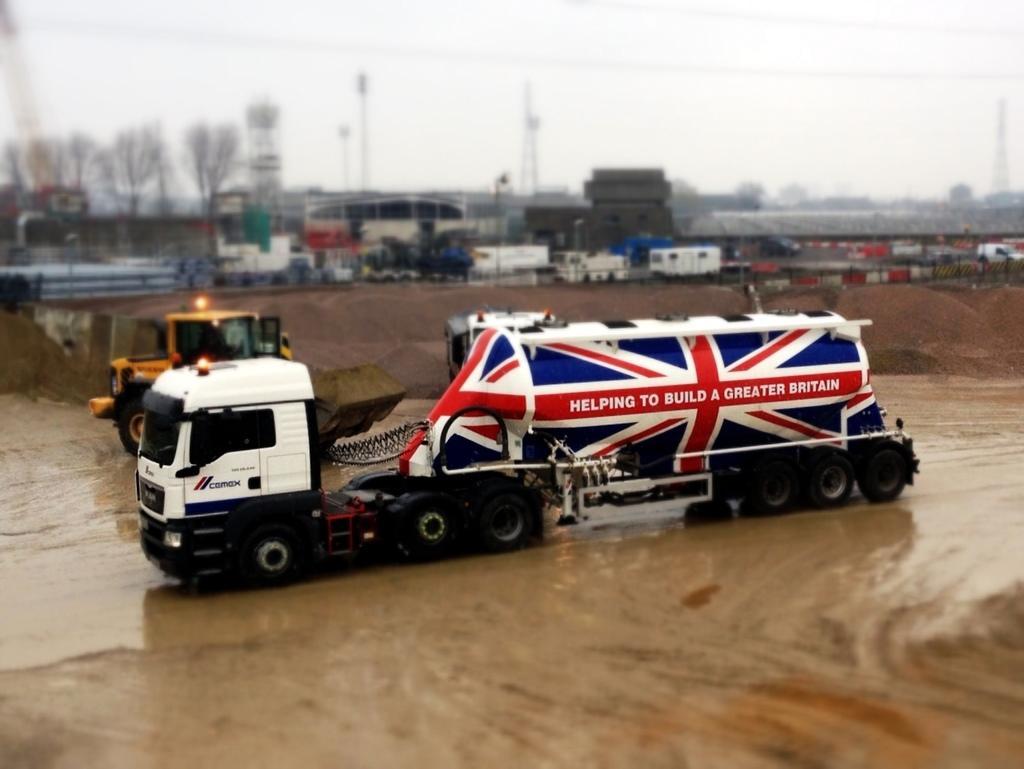Describe this image in one or two sentences. In the foreground of this image, there is a truck moving on the ground and there are few vehicles moving on the ground. In the background, there are pipes, shed, poles, containers, trees, towers and the sky. 